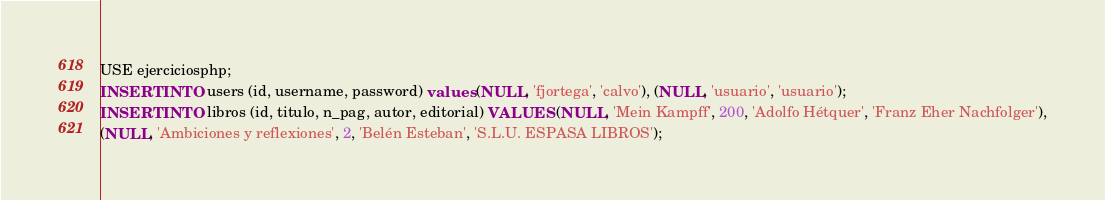Convert code to text. <code><loc_0><loc_0><loc_500><loc_500><_SQL_>USE ejerciciosphp;
INSERT INTO users (id, username, password) values (NULL, 'fjortega', 'calvo'), (NULL, 'usuario', 'usuario');
INSERT INTO libros (id, titulo, n_pag, autor, editorial) VALUES (NULL, 'Mein Kampff', 200, 'Adolfo Hétquer', 'Franz Eher Nachfolger'),
(NULL, 'Ambiciones y reflexiones', 2, 'Belén Esteban', 'S.L.U. ESPASA LIBROS');
</code> 